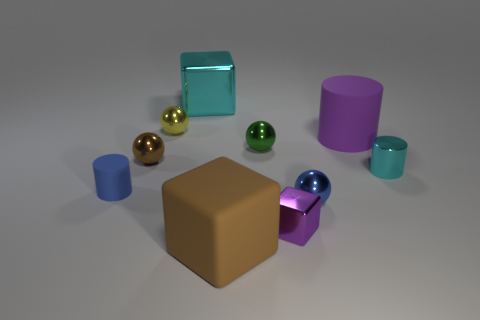The matte cylinder that is the same color as the small shiny cube is what size?
Offer a terse response. Large. The tiny cylinder to the right of the purple object that is left of the blue metallic sphere is what color?
Keep it short and to the point. Cyan. Are there any other large cylinders of the same color as the large rubber cylinder?
Your answer should be compact. No. The shiny cylinder that is the same size as the yellow thing is what color?
Your answer should be very brief. Cyan. Does the cylinder on the left side of the small blue metal thing have the same material as the cyan block?
Your answer should be compact. No. Is there a small cyan shiny thing right of the small cylinder that is to the right of the large thing in front of the tiny cyan object?
Provide a short and direct response. No. Is the shape of the large matte thing that is on the right side of the brown rubber thing the same as  the small brown shiny thing?
Ensure brevity in your answer.  No. What shape is the cyan metal object behind the big rubber thing behind the tiny green metallic object?
Provide a short and direct response. Cube. There is a metal block that is to the left of the brown object that is right of the shiny cube that is behind the blue rubber cylinder; what is its size?
Keep it short and to the point. Large. What is the color of the metallic object that is the same shape as the small rubber object?
Give a very brief answer. Cyan. 